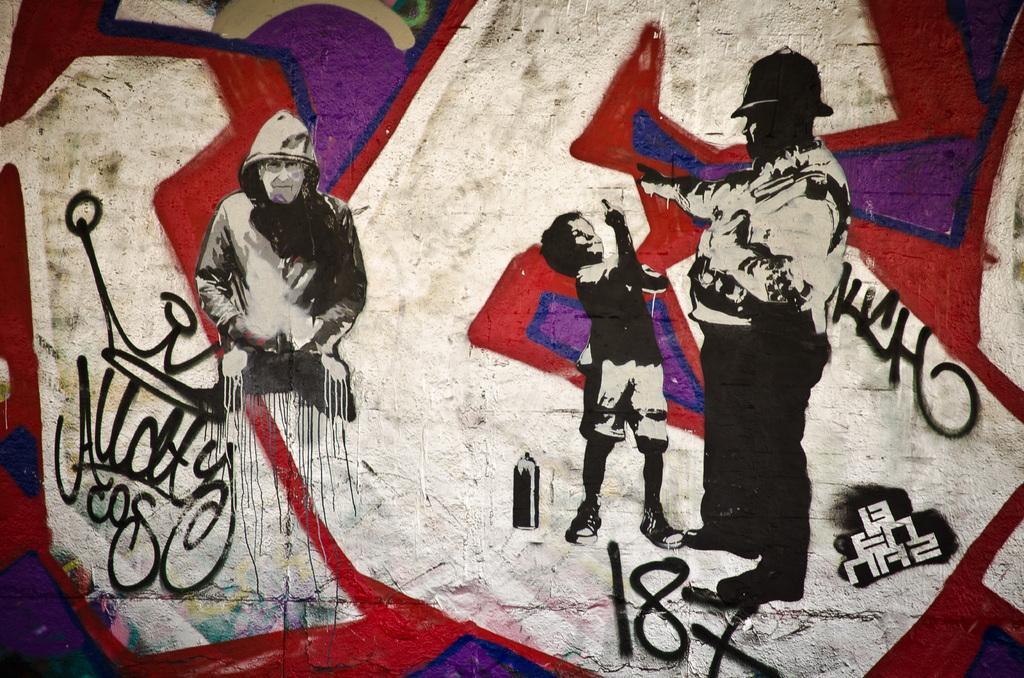Can you describe this image briefly? In the picture there are some paintings of human beings and also different signs on a wall. 